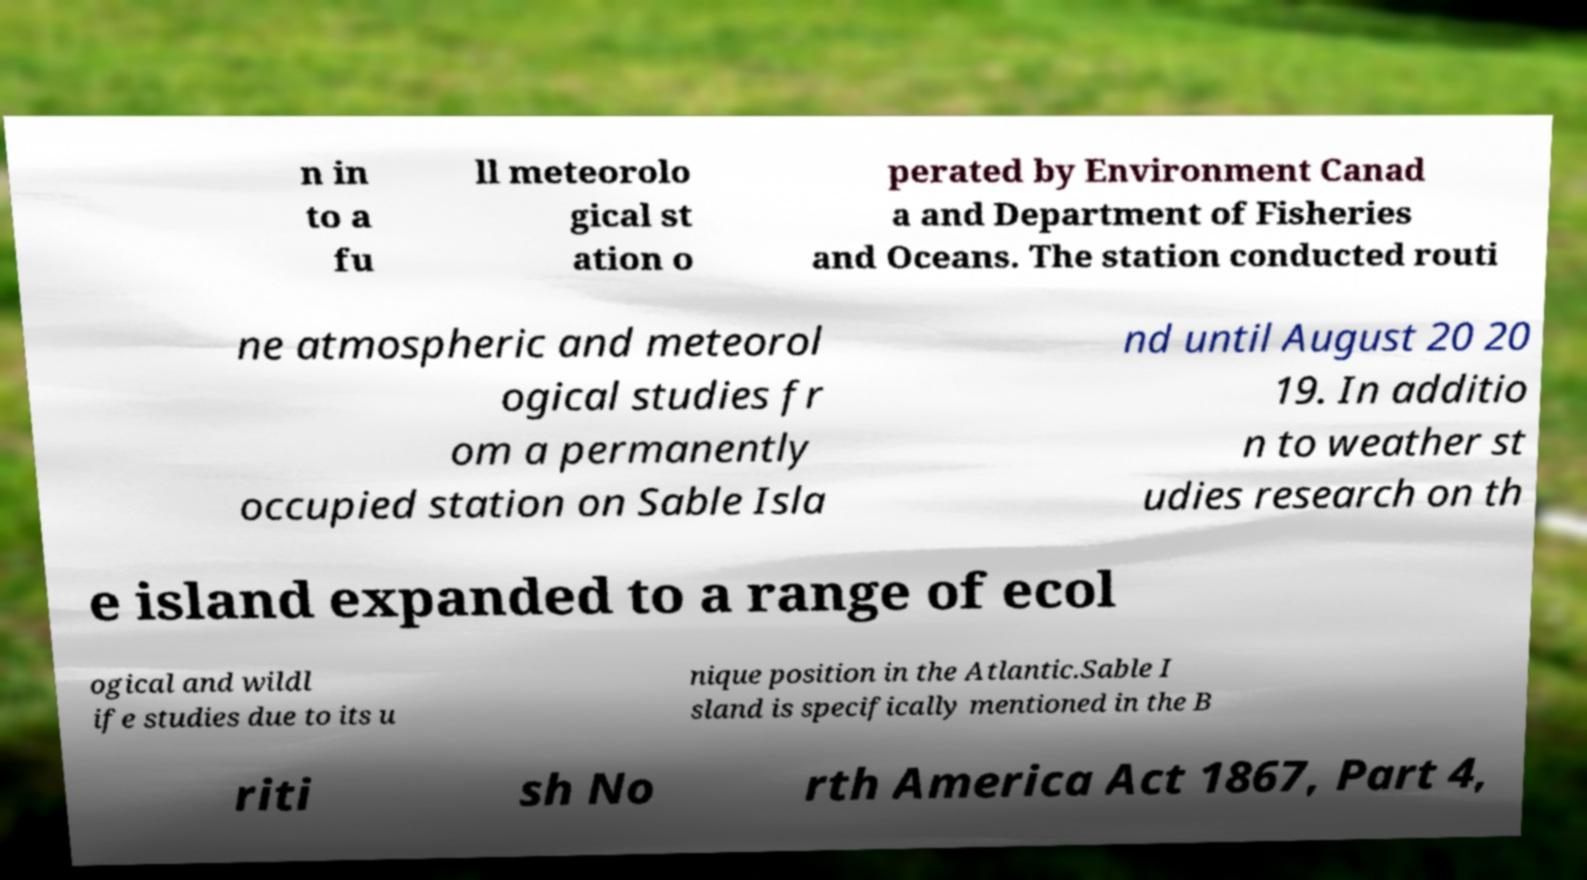Please identify and transcribe the text found in this image. n in to a fu ll meteorolo gical st ation o perated by Environment Canad a and Department of Fisheries and Oceans. The station conducted routi ne atmospheric and meteorol ogical studies fr om a permanently occupied station on Sable Isla nd until August 20 20 19. In additio n to weather st udies research on th e island expanded to a range of ecol ogical and wildl ife studies due to its u nique position in the Atlantic.Sable I sland is specifically mentioned in the B riti sh No rth America Act 1867, Part 4, 